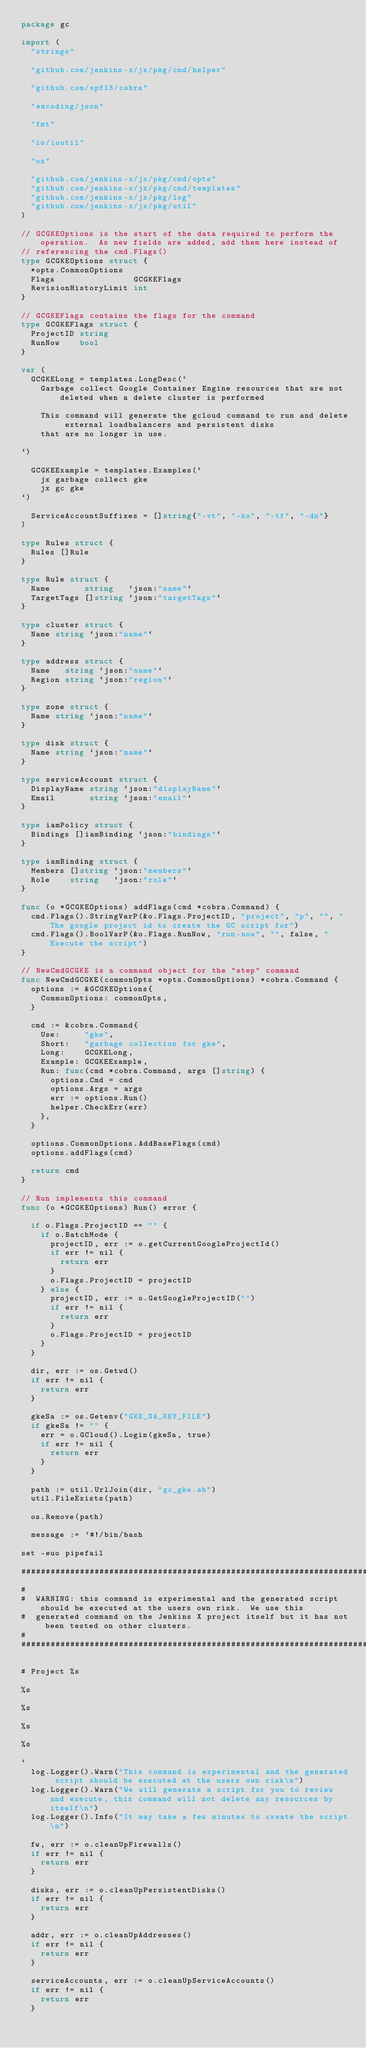Convert code to text. <code><loc_0><loc_0><loc_500><loc_500><_Go_>package gc

import (
	"strings"

	"github.com/jenkins-x/jx/pkg/cmd/helper"

	"github.com/spf13/cobra"

	"encoding/json"

	"fmt"

	"io/ioutil"

	"os"

	"github.com/jenkins-x/jx/pkg/cmd/opts"
	"github.com/jenkins-x/jx/pkg/cmd/templates"
	"github.com/jenkins-x/jx/pkg/log"
	"github.com/jenkins-x/jx/pkg/util"
)

// GCGKEOptions is the start of the data required to perform the operation.  As new fields are added, add them here instead of
// referencing the cmd.Flags()
type GCGKEOptions struct {
	*opts.CommonOptions
	Flags                GCGKEFlags
	RevisionHistoryLimit int
}

// GCGKEFlags contains the flags for the command
type GCGKEFlags struct {
	ProjectID string
	RunNow    bool
}

var (
	GCGKELong = templates.LongDesc(`
		Garbage collect Google Container Engine resources that are not deleted when a delete cluster is performed

		This command will generate the gcloud command to run and delete external loadbalancers and persistent disks
		that are no longer in use.

`)

	GCGKEExample = templates.Examples(`
		jx garbage collect gke
		jx gc gke
`)

	ServiceAccountSuffixes = []string{"-vt", "-ko", "-tf", "-dn"}
)

type Rules struct {
	Rules []Rule
}

type Rule struct {
	Name       string   `json:"name"`
	TargetTags []string `json:"targetTags"`
}

type cluster struct {
	Name string `json:"name"`
}

type address struct {
	Name   string `json:"name"`
	Region string `json:"region"`
}

type zone struct {
	Name string `json:"name"`
}

type disk struct {
	Name string `json:"name"`
}

type serviceAccount struct {
	DisplayName string `json:"displayName"`
	Email       string `json:"email"`
}

type iamPolicy struct {
	Bindings []iamBinding `json:"bindings"`
}

type iamBinding struct {
	Members []string `json:"members"`
	Role    string   `json:"role"`
}

func (o *GCGKEOptions) addFlags(cmd *cobra.Command) {
	cmd.Flags().StringVarP(&o.Flags.ProjectID, "project", "p", "", "The google project id to create the GC script for")
	cmd.Flags().BoolVarP(&o.Flags.RunNow, "run-now", "", false, "Execute the script")
}

// NewCmdGCGKE is a command object for the "step" command
func NewCmdGCGKE(commonOpts *opts.CommonOptions) *cobra.Command {
	options := &GCGKEOptions{
		CommonOptions: commonOpts,
	}

	cmd := &cobra.Command{
		Use:     "gke",
		Short:   "garbage collection for gke",
		Long:    GCGKELong,
		Example: GCGKEExample,
		Run: func(cmd *cobra.Command, args []string) {
			options.Cmd = cmd
			options.Args = args
			err := options.Run()
			helper.CheckErr(err)
		},
	}

	options.CommonOptions.AddBaseFlags(cmd)
	options.addFlags(cmd)

	return cmd
}

// Run implements this command
func (o *GCGKEOptions) Run() error {

	if o.Flags.ProjectID == "" {
		if o.BatchMode {
			projectID, err := o.getCurrentGoogleProjectId()
			if err != nil {
				return err
			}
			o.Flags.ProjectID = projectID
		} else {
			projectID, err := o.GetGoogleProjectID("")
			if err != nil {
				return err
			}
			o.Flags.ProjectID = projectID
		}
	}

	dir, err := os.Getwd()
	if err != nil {
		return err
	}

	gkeSa := os.Getenv("GKE_SA_KEY_FILE")
	if gkeSa != "" {
		err = o.GCloud().Login(gkeSa, true)
		if err != nil {
			return err
		}
	}

	path := util.UrlJoin(dir, "gc_gke.sh")
	util.FileExists(path)

	os.Remove(path)

	message := `#!/bin/bash

set -euo pipefail

###################################################################################################
#
#  WARNING: this command is experimental and the generated script should be executed at the users own risk.  We use this
#  generated command on the Jenkins X project itself but it has not been tested on other clusters.
#
###################################################################################################

# Project %s

%s

%s

%s

%s

`
	log.Logger().Warn("This command is experimental and the generated script should be executed at the users own risk\n")
	log.Logger().Warn("We will generate a script for you to review and execute, this command will not delete any resources by itself\n")
	log.Logger().Info("It may take a few minutes to create the script\n")

	fw, err := o.cleanUpFirewalls()
	if err != nil {
		return err
	}

	disks, err := o.cleanUpPersistentDisks()
	if err != nil {
		return err
	}

	addr, err := o.cleanUpAddresses()
	if err != nil {
		return err
	}

	serviceAccounts, err := o.cleanUpServiceAccounts()
	if err != nil {
		return err
	}
</code> 